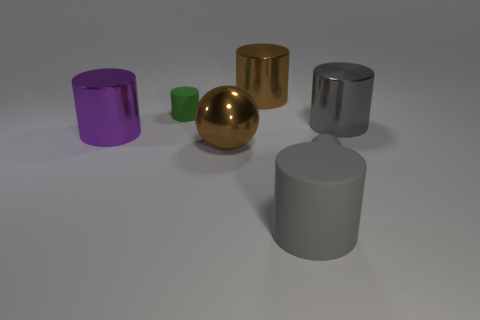There is a small thing in front of the small object behind the brown object in front of the brown metallic cylinder; what is its material?
Your response must be concise. Rubber. Is the purple metal cylinder the same size as the gray matte cylinder?
Give a very brief answer. Yes. There is a small matte ball; is its color the same as the large metallic object to the left of the metal ball?
Make the answer very short. No. The purple thing that is made of the same material as the large brown sphere is what shape?
Provide a succinct answer. Cylinder. There is a brown metallic thing that is in front of the tiny green matte object; is its shape the same as the tiny gray object?
Provide a short and direct response. Yes. There is a metal thing that is behind the big gray cylinder behind the purple thing; what is its size?
Give a very brief answer. Large. What color is the big thing that is the same material as the tiny gray object?
Make the answer very short. Gray. How many matte cylinders have the same size as the brown shiny cylinder?
Make the answer very short. 1. What number of gray objects are metallic spheres or big cylinders?
Your response must be concise. 2. What number of things are small blocks or small things on the right side of the green rubber cylinder?
Provide a succinct answer. 1. 